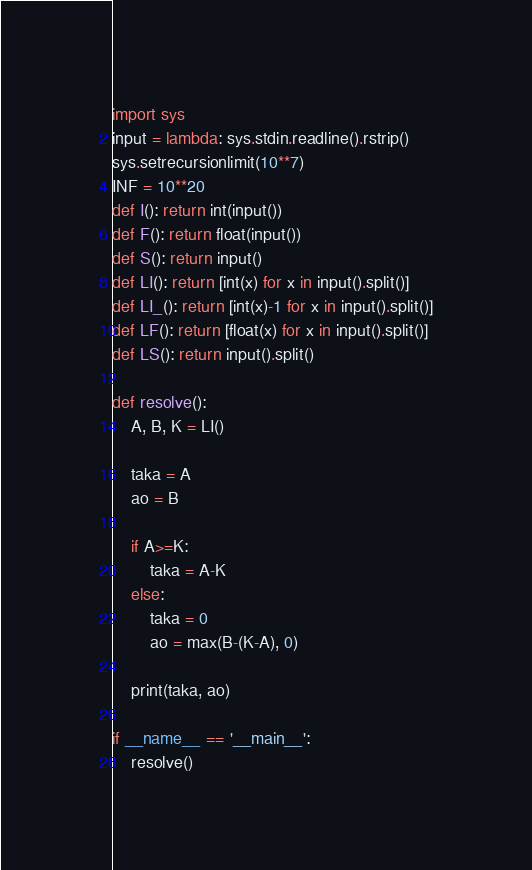<code> <loc_0><loc_0><loc_500><loc_500><_Python_>import sys
input = lambda: sys.stdin.readline().rstrip() 
sys.setrecursionlimit(10**7)
INF = 10**20
def I(): return int(input())
def F(): return float(input())
def S(): return input()
def LI(): return [int(x) for x in input().split()]
def LI_(): return [int(x)-1 for x in input().split()]
def LF(): return [float(x) for x in input().split()]
def LS(): return input().split()

def resolve():
    A, B, K = LI()

    taka = A
    ao = B

    if A>=K:
        taka = A-K
    else:
        taka = 0
        ao = max(B-(K-A), 0)

    print(taka, ao)

if __name__ == '__main__':
    resolve()</code> 